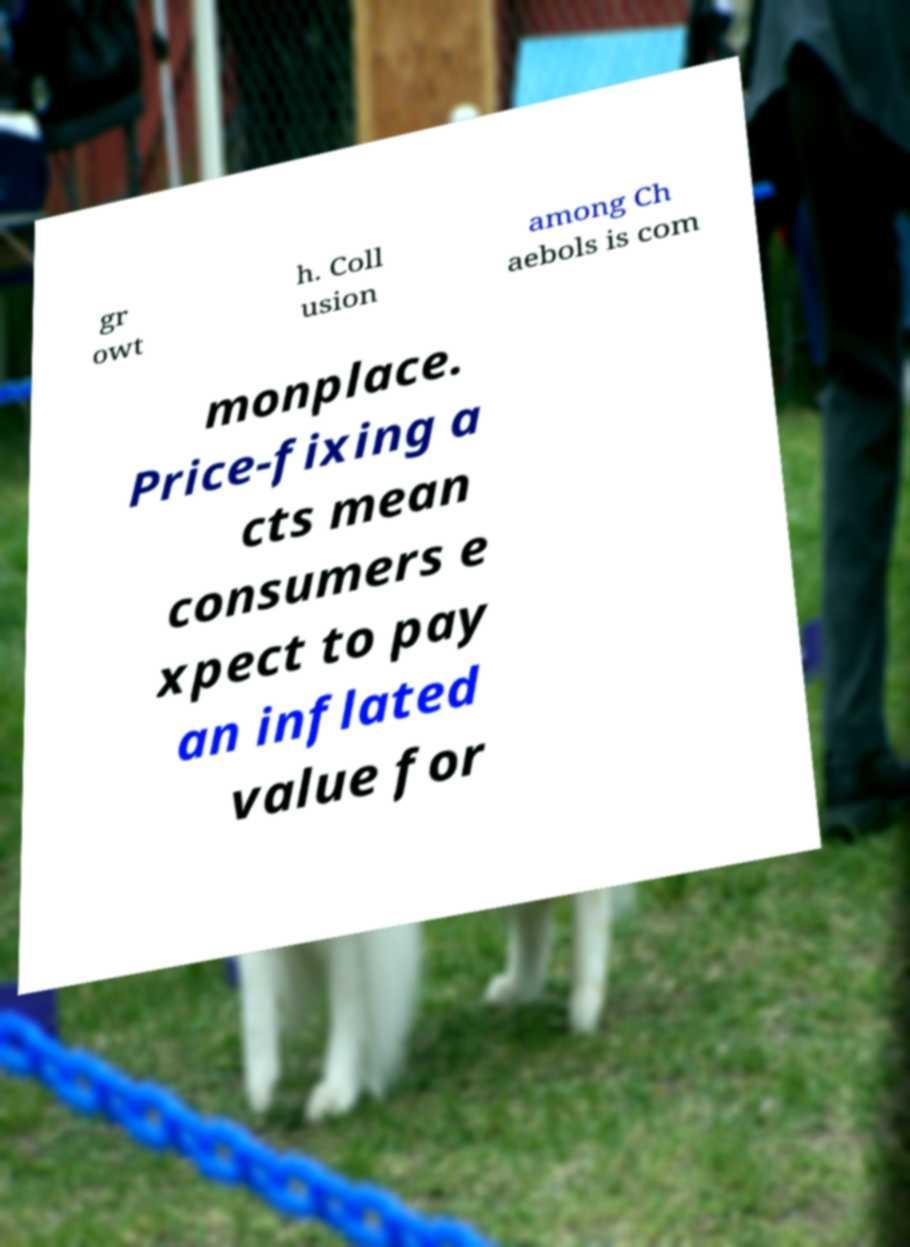For documentation purposes, I need the text within this image transcribed. Could you provide that? gr owt h. Coll usion among Ch aebols is com monplace. Price-fixing a cts mean consumers e xpect to pay an inflated value for 